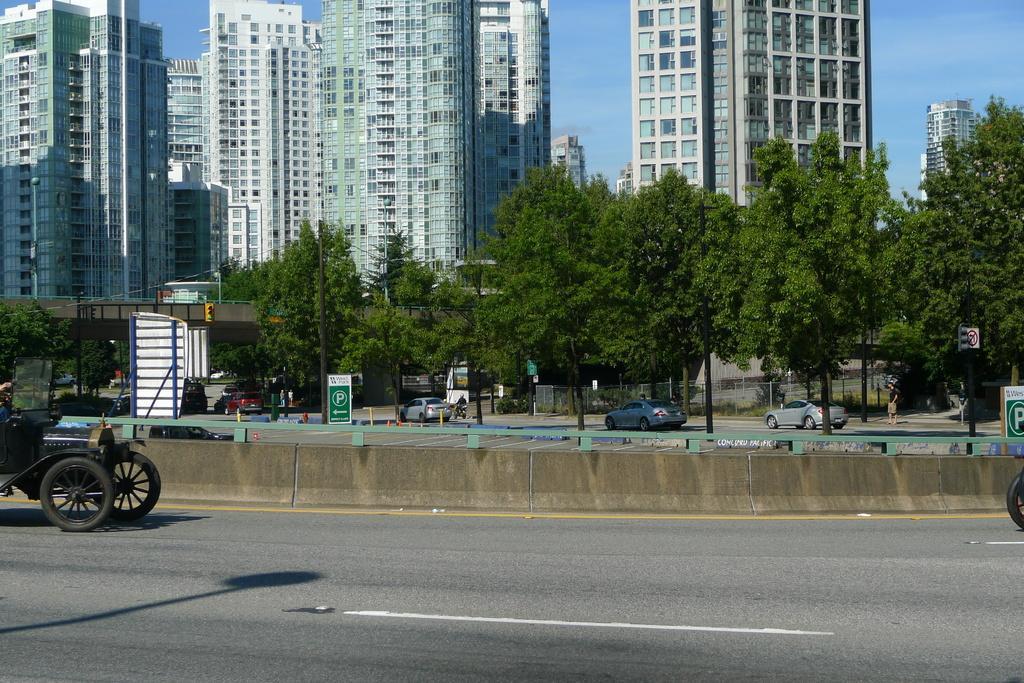Could you give a brief overview of what you see in this image? In this image in the center there are vehicles moving on the road and there are trees and there are boards with some text written on it. In the background there are buildings and the sky is cloudy. 